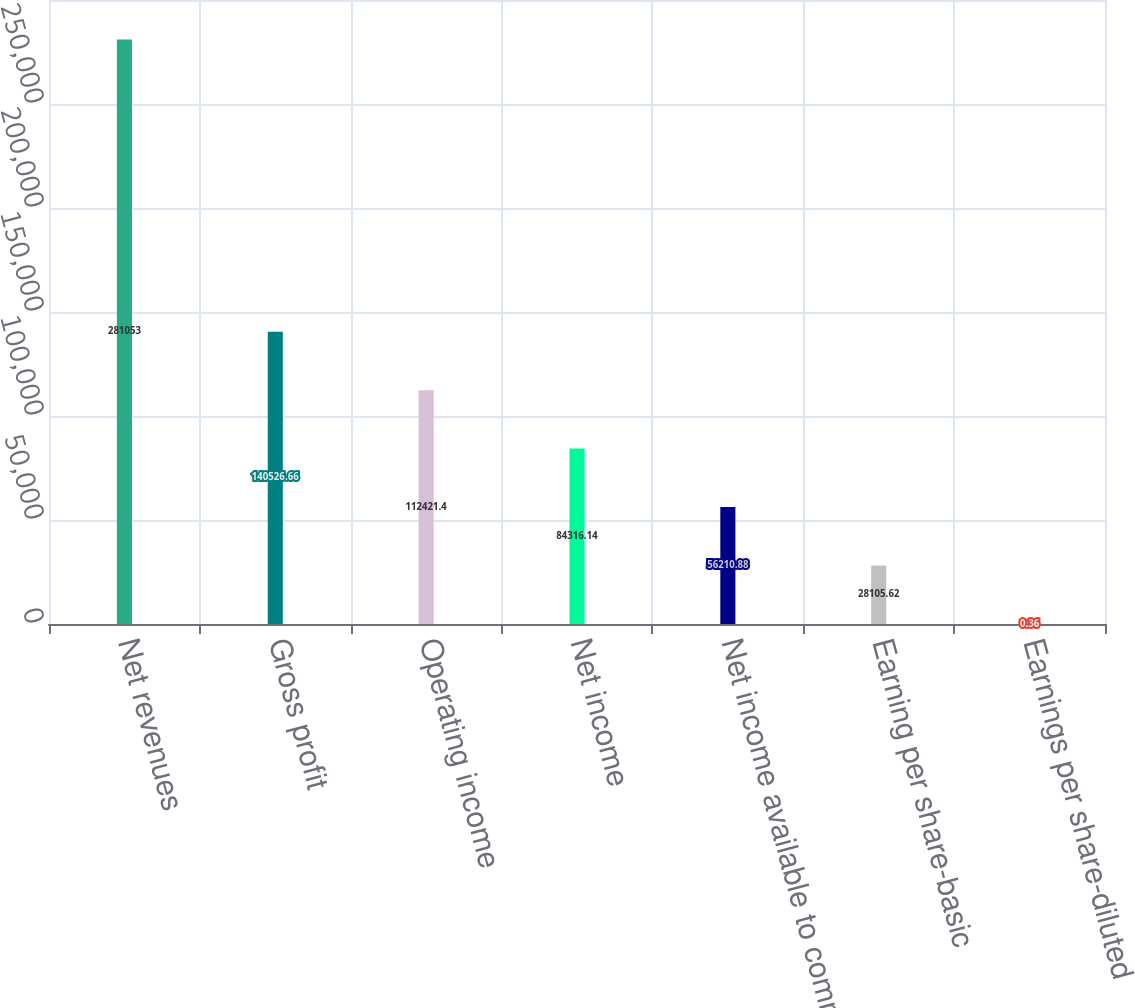Convert chart to OTSL. <chart><loc_0><loc_0><loc_500><loc_500><bar_chart><fcel>Net revenues<fcel>Gross profit<fcel>Operating income<fcel>Net income<fcel>Net income available to common<fcel>Earning per share-basic<fcel>Earnings per share-diluted<nl><fcel>281053<fcel>140527<fcel>112421<fcel>84316.1<fcel>56210.9<fcel>28105.6<fcel>0.36<nl></chart> 